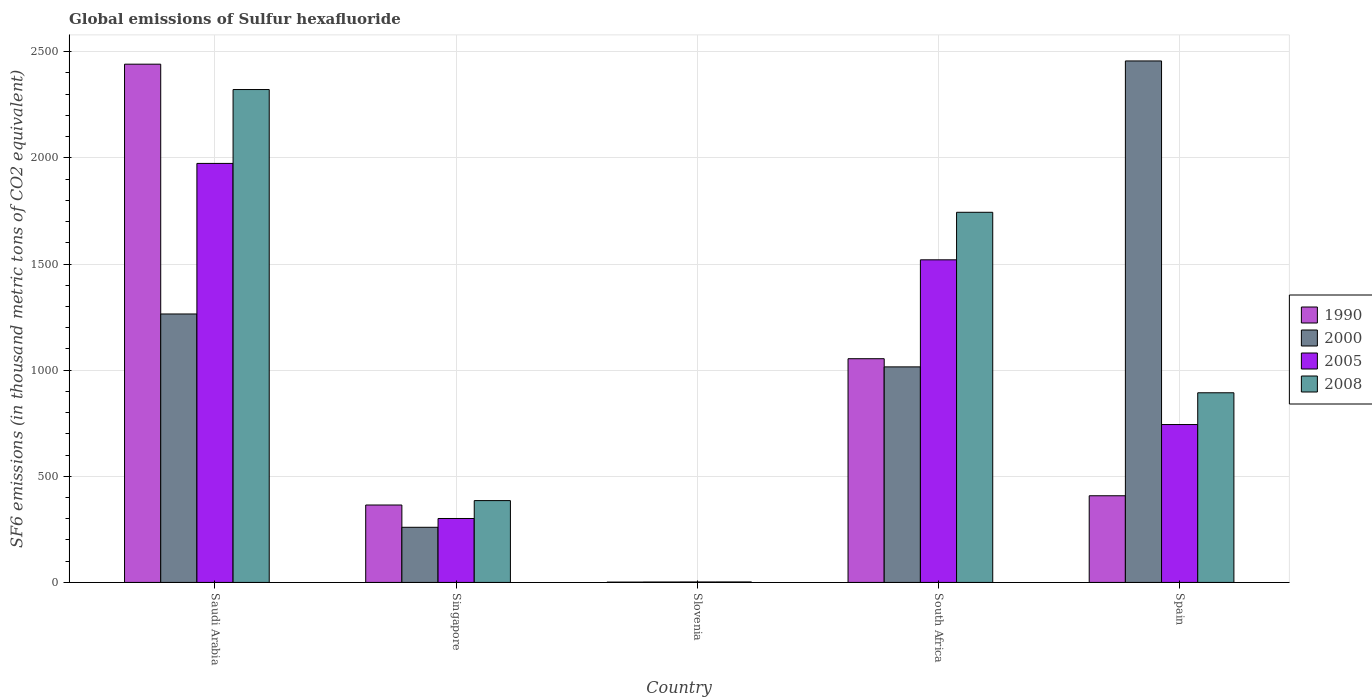How many different coloured bars are there?
Your answer should be compact. 4. How many groups of bars are there?
Keep it short and to the point. 5. How many bars are there on the 1st tick from the left?
Your answer should be very brief. 4. How many bars are there on the 1st tick from the right?
Make the answer very short. 4. What is the label of the 3rd group of bars from the left?
Ensure brevity in your answer.  Slovenia. In how many cases, is the number of bars for a given country not equal to the number of legend labels?
Provide a succinct answer. 0. What is the global emissions of Sulfur hexafluoride in 2000 in Singapore?
Give a very brief answer. 259.8. Across all countries, what is the maximum global emissions of Sulfur hexafluoride in 1990?
Make the answer very short. 2441.3. In which country was the global emissions of Sulfur hexafluoride in 2000 maximum?
Your answer should be compact. Spain. In which country was the global emissions of Sulfur hexafluoride in 2000 minimum?
Keep it short and to the point. Slovenia. What is the total global emissions of Sulfur hexafluoride in 2000 in the graph?
Offer a terse response. 4998.3. What is the difference between the global emissions of Sulfur hexafluoride in 2000 in Slovenia and that in Spain?
Make the answer very short. -2454.5. What is the difference between the global emissions of Sulfur hexafluoride in 2005 in Slovenia and the global emissions of Sulfur hexafluoride in 1990 in Singapore?
Ensure brevity in your answer.  -362.5. What is the average global emissions of Sulfur hexafluoride in 2005 per country?
Give a very brief answer. 908.14. What is the difference between the global emissions of Sulfur hexafluoride of/in 2000 and global emissions of Sulfur hexafluoride of/in 1990 in Spain?
Offer a very short reply. 2048.2. What is the ratio of the global emissions of Sulfur hexafluoride in 2005 in South Africa to that in Spain?
Keep it short and to the point. 2.04. Is the difference between the global emissions of Sulfur hexafluoride in 2000 in Singapore and Slovenia greater than the difference between the global emissions of Sulfur hexafluoride in 1990 in Singapore and Slovenia?
Ensure brevity in your answer.  No. What is the difference between the highest and the second highest global emissions of Sulfur hexafluoride in 1990?
Offer a very short reply. -2033. What is the difference between the highest and the lowest global emissions of Sulfur hexafluoride in 1990?
Make the answer very short. 2439.7. Is it the case that in every country, the sum of the global emissions of Sulfur hexafluoride in 2008 and global emissions of Sulfur hexafluoride in 2005 is greater than the sum of global emissions of Sulfur hexafluoride in 2000 and global emissions of Sulfur hexafluoride in 1990?
Provide a succinct answer. No. Is it the case that in every country, the sum of the global emissions of Sulfur hexafluoride in 1990 and global emissions of Sulfur hexafluoride in 2008 is greater than the global emissions of Sulfur hexafluoride in 2000?
Your response must be concise. No. How many bars are there?
Your response must be concise. 20. What is the difference between two consecutive major ticks on the Y-axis?
Your response must be concise. 500. Are the values on the major ticks of Y-axis written in scientific E-notation?
Offer a terse response. No. Does the graph contain any zero values?
Your answer should be compact. No. Does the graph contain grids?
Offer a very short reply. Yes. Where does the legend appear in the graph?
Offer a very short reply. Center right. How many legend labels are there?
Give a very brief answer. 4. How are the legend labels stacked?
Your answer should be very brief. Vertical. What is the title of the graph?
Provide a short and direct response. Global emissions of Sulfur hexafluoride. Does "1997" appear as one of the legend labels in the graph?
Ensure brevity in your answer.  No. What is the label or title of the Y-axis?
Provide a succinct answer. SF6 emissions (in thousand metric tons of CO2 equivalent). What is the SF6 emissions (in thousand metric tons of CO2 equivalent) of 1990 in Saudi Arabia?
Provide a short and direct response. 2441.3. What is the SF6 emissions (in thousand metric tons of CO2 equivalent) in 2000 in Saudi Arabia?
Give a very brief answer. 1264.6. What is the SF6 emissions (in thousand metric tons of CO2 equivalent) of 2005 in Saudi Arabia?
Keep it short and to the point. 1973.8. What is the SF6 emissions (in thousand metric tons of CO2 equivalent) of 2008 in Saudi Arabia?
Provide a short and direct response. 2321.8. What is the SF6 emissions (in thousand metric tons of CO2 equivalent) of 1990 in Singapore?
Give a very brief answer. 364.7. What is the SF6 emissions (in thousand metric tons of CO2 equivalent) in 2000 in Singapore?
Your response must be concise. 259.8. What is the SF6 emissions (in thousand metric tons of CO2 equivalent) in 2005 in Singapore?
Offer a terse response. 301.2. What is the SF6 emissions (in thousand metric tons of CO2 equivalent) in 2008 in Singapore?
Make the answer very short. 385.5. What is the SF6 emissions (in thousand metric tons of CO2 equivalent) in 2000 in Slovenia?
Offer a terse response. 2. What is the SF6 emissions (in thousand metric tons of CO2 equivalent) of 2005 in Slovenia?
Provide a short and direct response. 2.2. What is the SF6 emissions (in thousand metric tons of CO2 equivalent) in 1990 in South Africa?
Your response must be concise. 1053.9. What is the SF6 emissions (in thousand metric tons of CO2 equivalent) in 2000 in South Africa?
Keep it short and to the point. 1015.4. What is the SF6 emissions (in thousand metric tons of CO2 equivalent) in 2005 in South Africa?
Make the answer very short. 1519.7. What is the SF6 emissions (in thousand metric tons of CO2 equivalent) of 2008 in South Africa?
Provide a short and direct response. 1743.6. What is the SF6 emissions (in thousand metric tons of CO2 equivalent) of 1990 in Spain?
Ensure brevity in your answer.  408.3. What is the SF6 emissions (in thousand metric tons of CO2 equivalent) in 2000 in Spain?
Keep it short and to the point. 2456.5. What is the SF6 emissions (in thousand metric tons of CO2 equivalent) in 2005 in Spain?
Provide a succinct answer. 743.8. What is the SF6 emissions (in thousand metric tons of CO2 equivalent) in 2008 in Spain?
Offer a very short reply. 893.4. Across all countries, what is the maximum SF6 emissions (in thousand metric tons of CO2 equivalent) in 1990?
Your answer should be very brief. 2441.3. Across all countries, what is the maximum SF6 emissions (in thousand metric tons of CO2 equivalent) in 2000?
Your response must be concise. 2456.5. Across all countries, what is the maximum SF6 emissions (in thousand metric tons of CO2 equivalent) of 2005?
Provide a short and direct response. 1973.8. Across all countries, what is the maximum SF6 emissions (in thousand metric tons of CO2 equivalent) in 2008?
Provide a succinct answer. 2321.8. Across all countries, what is the minimum SF6 emissions (in thousand metric tons of CO2 equivalent) in 2000?
Offer a terse response. 2. Across all countries, what is the minimum SF6 emissions (in thousand metric tons of CO2 equivalent) of 2008?
Offer a very short reply. 2.3. What is the total SF6 emissions (in thousand metric tons of CO2 equivalent) of 1990 in the graph?
Offer a terse response. 4269.8. What is the total SF6 emissions (in thousand metric tons of CO2 equivalent) of 2000 in the graph?
Give a very brief answer. 4998.3. What is the total SF6 emissions (in thousand metric tons of CO2 equivalent) of 2005 in the graph?
Your response must be concise. 4540.7. What is the total SF6 emissions (in thousand metric tons of CO2 equivalent) in 2008 in the graph?
Offer a terse response. 5346.6. What is the difference between the SF6 emissions (in thousand metric tons of CO2 equivalent) of 1990 in Saudi Arabia and that in Singapore?
Provide a succinct answer. 2076.6. What is the difference between the SF6 emissions (in thousand metric tons of CO2 equivalent) of 2000 in Saudi Arabia and that in Singapore?
Make the answer very short. 1004.8. What is the difference between the SF6 emissions (in thousand metric tons of CO2 equivalent) in 2005 in Saudi Arabia and that in Singapore?
Your answer should be compact. 1672.6. What is the difference between the SF6 emissions (in thousand metric tons of CO2 equivalent) in 2008 in Saudi Arabia and that in Singapore?
Provide a short and direct response. 1936.3. What is the difference between the SF6 emissions (in thousand metric tons of CO2 equivalent) of 1990 in Saudi Arabia and that in Slovenia?
Provide a succinct answer. 2439.7. What is the difference between the SF6 emissions (in thousand metric tons of CO2 equivalent) in 2000 in Saudi Arabia and that in Slovenia?
Ensure brevity in your answer.  1262.6. What is the difference between the SF6 emissions (in thousand metric tons of CO2 equivalent) in 2005 in Saudi Arabia and that in Slovenia?
Keep it short and to the point. 1971.6. What is the difference between the SF6 emissions (in thousand metric tons of CO2 equivalent) of 2008 in Saudi Arabia and that in Slovenia?
Your answer should be very brief. 2319.5. What is the difference between the SF6 emissions (in thousand metric tons of CO2 equivalent) in 1990 in Saudi Arabia and that in South Africa?
Your answer should be compact. 1387.4. What is the difference between the SF6 emissions (in thousand metric tons of CO2 equivalent) in 2000 in Saudi Arabia and that in South Africa?
Provide a short and direct response. 249.2. What is the difference between the SF6 emissions (in thousand metric tons of CO2 equivalent) of 2005 in Saudi Arabia and that in South Africa?
Your response must be concise. 454.1. What is the difference between the SF6 emissions (in thousand metric tons of CO2 equivalent) in 2008 in Saudi Arabia and that in South Africa?
Provide a succinct answer. 578.2. What is the difference between the SF6 emissions (in thousand metric tons of CO2 equivalent) in 1990 in Saudi Arabia and that in Spain?
Give a very brief answer. 2033. What is the difference between the SF6 emissions (in thousand metric tons of CO2 equivalent) of 2000 in Saudi Arabia and that in Spain?
Your answer should be compact. -1191.9. What is the difference between the SF6 emissions (in thousand metric tons of CO2 equivalent) of 2005 in Saudi Arabia and that in Spain?
Your response must be concise. 1230. What is the difference between the SF6 emissions (in thousand metric tons of CO2 equivalent) in 2008 in Saudi Arabia and that in Spain?
Ensure brevity in your answer.  1428.4. What is the difference between the SF6 emissions (in thousand metric tons of CO2 equivalent) in 1990 in Singapore and that in Slovenia?
Ensure brevity in your answer.  363.1. What is the difference between the SF6 emissions (in thousand metric tons of CO2 equivalent) in 2000 in Singapore and that in Slovenia?
Provide a succinct answer. 257.8. What is the difference between the SF6 emissions (in thousand metric tons of CO2 equivalent) of 2005 in Singapore and that in Slovenia?
Ensure brevity in your answer.  299. What is the difference between the SF6 emissions (in thousand metric tons of CO2 equivalent) of 2008 in Singapore and that in Slovenia?
Offer a terse response. 383.2. What is the difference between the SF6 emissions (in thousand metric tons of CO2 equivalent) in 1990 in Singapore and that in South Africa?
Offer a terse response. -689.2. What is the difference between the SF6 emissions (in thousand metric tons of CO2 equivalent) of 2000 in Singapore and that in South Africa?
Ensure brevity in your answer.  -755.6. What is the difference between the SF6 emissions (in thousand metric tons of CO2 equivalent) in 2005 in Singapore and that in South Africa?
Your answer should be very brief. -1218.5. What is the difference between the SF6 emissions (in thousand metric tons of CO2 equivalent) in 2008 in Singapore and that in South Africa?
Make the answer very short. -1358.1. What is the difference between the SF6 emissions (in thousand metric tons of CO2 equivalent) of 1990 in Singapore and that in Spain?
Keep it short and to the point. -43.6. What is the difference between the SF6 emissions (in thousand metric tons of CO2 equivalent) of 2000 in Singapore and that in Spain?
Your response must be concise. -2196.7. What is the difference between the SF6 emissions (in thousand metric tons of CO2 equivalent) in 2005 in Singapore and that in Spain?
Provide a succinct answer. -442.6. What is the difference between the SF6 emissions (in thousand metric tons of CO2 equivalent) of 2008 in Singapore and that in Spain?
Make the answer very short. -507.9. What is the difference between the SF6 emissions (in thousand metric tons of CO2 equivalent) of 1990 in Slovenia and that in South Africa?
Offer a very short reply. -1052.3. What is the difference between the SF6 emissions (in thousand metric tons of CO2 equivalent) of 2000 in Slovenia and that in South Africa?
Provide a short and direct response. -1013.4. What is the difference between the SF6 emissions (in thousand metric tons of CO2 equivalent) in 2005 in Slovenia and that in South Africa?
Ensure brevity in your answer.  -1517.5. What is the difference between the SF6 emissions (in thousand metric tons of CO2 equivalent) in 2008 in Slovenia and that in South Africa?
Your response must be concise. -1741.3. What is the difference between the SF6 emissions (in thousand metric tons of CO2 equivalent) in 1990 in Slovenia and that in Spain?
Your response must be concise. -406.7. What is the difference between the SF6 emissions (in thousand metric tons of CO2 equivalent) of 2000 in Slovenia and that in Spain?
Your answer should be very brief. -2454.5. What is the difference between the SF6 emissions (in thousand metric tons of CO2 equivalent) in 2005 in Slovenia and that in Spain?
Provide a succinct answer. -741.6. What is the difference between the SF6 emissions (in thousand metric tons of CO2 equivalent) of 2008 in Slovenia and that in Spain?
Offer a very short reply. -891.1. What is the difference between the SF6 emissions (in thousand metric tons of CO2 equivalent) in 1990 in South Africa and that in Spain?
Provide a short and direct response. 645.6. What is the difference between the SF6 emissions (in thousand metric tons of CO2 equivalent) of 2000 in South Africa and that in Spain?
Ensure brevity in your answer.  -1441.1. What is the difference between the SF6 emissions (in thousand metric tons of CO2 equivalent) in 2005 in South Africa and that in Spain?
Provide a succinct answer. 775.9. What is the difference between the SF6 emissions (in thousand metric tons of CO2 equivalent) of 2008 in South Africa and that in Spain?
Your answer should be very brief. 850.2. What is the difference between the SF6 emissions (in thousand metric tons of CO2 equivalent) in 1990 in Saudi Arabia and the SF6 emissions (in thousand metric tons of CO2 equivalent) in 2000 in Singapore?
Make the answer very short. 2181.5. What is the difference between the SF6 emissions (in thousand metric tons of CO2 equivalent) of 1990 in Saudi Arabia and the SF6 emissions (in thousand metric tons of CO2 equivalent) of 2005 in Singapore?
Your response must be concise. 2140.1. What is the difference between the SF6 emissions (in thousand metric tons of CO2 equivalent) in 1990 in Saudi Arabia and the SF6 emissions (in thousand metric tons of CO2 equivalent) in 2008 in Singapore?
Your response must be concise. 2055.8. What is the difference between the SF6 emissions (in thousand metric tons of CO2 equivalent) in 2000 in Saudi Arabia and the SF6 emissions (in thousand metric tons of CO2 equivalent) in 2005 in Singapore?
Make the answer very short. 963.4. What is the difference between the SF6 emissions (in thousand metric tons of CO2 equivalent) of 2000 in Saudi Arabia and the SF6 emissions (in thousand metric tons of CO2 equivalent) of 2008 in Singapore?
Offer a terse response. 879.1. What is the difference between the SF6 emissions (in thousand metric tons of CO2 equivalent) of 2005 in Saudi Arabia and the SF6 emissions (in thousand metric tons of CO2 equivalent) of 2008 in Singapore?
Your response must be concise. 1588.3. What is the difference between the SF6 emissions (in thousand metric tons of CO2 equivalent) of 1990 in Saudi Arabia and the SF6 emissions (in thousand metric tons of CO2 equivalent) of 2000 in Slovenia?
Your answer should be compact. 2439.3. What is the difference between the SF6 emissions (in thousand metric tons of CO2 equivalent) of 1990 in Saudi Arabia and the SF6 emissions (in thousand metric tons of CO2 equivalent) of 2005 in Slovenia?
Make the answer very short. 2439.1. What is the difference between the SF6 emissions (in thousand metric tons of CO2 equivalent) in 1990 in Saudi Arabia and the SF6 emissions (in thousand metric tons of CO2 equivalent) in 2008 in Slovenia?
Your answer should be compact. 2439. What is the difference between the SF6 emissions (in thousand metric tons of CO2 equivalent) of 2000 in Saudi Arabia and the SF6 emissions (in thousand metric tons of CO2 equivalent) of 2005 in Slovenia?
Offer a terse response. 1262.4. What is the difference between the SF6 emissions (in thousand metric tons of CO2 equivalent) of 2000 in Saudi Arabia and the SF6 emissions (in thousand metric tons of CO2 equivalent) of 2008 in Slovenia?
Ensure brevity in your answer.  1262.3. What is the difference between the SF6 emissions (in thousand metric tons of CO2 equivalent) in 2005 in Saudi Arabia and the SF6 emissions (in thousand metric tons of CO2 equivalent) in 2008 in Slovenia?
Keep it short and to the point. 1971.5. What is the difference between the SF6 emissions (in thousand metric tons of CO2 equivalent) in 1990 in Saudi Arabia and the SF6 emissions (in thousand metric tons of CO2 equivalent) in 2000 in South Africa?
Provide a succinct answer. 1425.9. What is the difference between the SF6 emissions (in thousand metric tons of CO2 equivalent) of 1990 in Saudi Arabia and the SF6 emissions (in thousand metric tons of CO2 equivalent) of 2005 in South Africa?
Your response must be concise. 921.6. What is the difference between the SF6 emissions (in thousand metric tons of CO2 equivalent) in 1990 in Saudi Arabia and the SF6 emissions (in thousand metric tons of CO2 equivalent) in 2008 in South Africa?
Your response must be concise. 697.7. What is the difference between the SF6 emissions (in thousand metric tons of CO2 equivalent) in 2000 in Saudi Arabia and the SF6 emissions (in thousand metric tons of CO2 equivalent) in 2005 in South Africa?
Make the answer very short. -255.1. What is the difference between the SF6 emissions (in thousand metric tons of CO2 equivalent) of 2000 in Saudi Arabia and the SF6 emissions (in thousand metric tons of CO2 equivalent) of 2008 in South Africa?
Provide a succinct answer. -479. What is the difference between the SF6 emissions (in thousand metric tons of CO2 equivalent) in 2005 in Saudi Arabia and the SF6 emissions (in thousand metric tons of CO2 equivalent) in 2008 in South Africa?
Your answer should be compact. 230.2. What is the difference between the SF6 emissions (in thousand metric tons of CO2 equivalent) in 1990 in Saudi Arabia and the SF6 emissions (in thousand metric tons of CO2 equivalent) in 2000 in Spain?
Your answer should be very brief. -15.2. What is the difference between the SF6 emissions (in thousand metric tons of CO2 equivalent) of 1990 in Saudi Arabia and the SF6 emissions (in thousand metric tons of CO2 equivalent) of 2005 in Spain?
Offer a very short reply. 1697.5. What is the difference between the SF6 emissions (in thousand metric tons of CO2 equivalent) in 1990 in Saudi Arabia and the SF6 emissions (in thousand metric tons of CO2 equivalent) in 2008 in Spain?
Give a very brief answer. 1547.9. What is the difference between the SF6 emissions (in thousand metric tons of CO2 equivalent) in 2000 in Saudi Arabia and the SF6 emissions (in thousand metric tons of CO2 equivalent) in 2005 in Spain?
Your answer should be compact. 520.8. What is the difference between the SF6 emissions (in thousand metric tons of CO2 equivalent) of 2000 in Saudi Arabia and the SF6 emissions (in thousand metric tons of CO2 equivalent) of 2008 in Spain?
Make the answer very short. 371.2. What is the difference between the SF6 emissions (in thousand metric tons of CO2 equivalent) of 2005 in Saudi Arabia and the SF6 emissions (in thousand metric tons of CO2 equivalent) of 2008 in Spain?
Make the answer very short. 1080.4. What is the difference between the SF6 emissions (in thousand metric tons of CO2 equivalent) in 1990 in Singapore and the SF6 emissions (in thousand metric tons of CO2 equivalent) in 2000 in Slovenia?
Provide a succinct answer. 362.7. What is the difference between the SF6 emissions (in thousand metric tons of CO2 equivalent) of 1990 in Singapore and the SF6 emissions (in thousand metric tons of CO2 equivalent) of 2005 in Slovenia?
Give a very brief answer. 362.5. What is the difference between the SF6 emissions (in thousand metric tons of CO2 equivalent) in 1990 in Singapore and the SF6 emissions (in thousand metric tons of CO2 equivalent) in 2008 in Slovenia?
Offer a very short reply. 362.4. What is the difference between the SF6 emissions (in thousand metric tons of CO2 equivalent) of 2000 in Singapore and the SF6 emissions (in thousand metric tons of CO2 equivalent) of 2005 in Slovenia?
Your response must be concise. 257.6. What is the difference between the SF6 emissions (in thousand metric tons of CO2 equivalent) in 2000 in Singapore and the SF6 emissions (in thousand metric tons of CO2 equivalent) in 2008 in Slovenia?
Make the answer very short. 257.5. What is the difference between the SF6 emissions (in thousand metric tons of CO2 equivalent) in 2005 in Singapore and the SF6 emissions (in thousand metric tons of CO2 equivalent) in 2008 in Slovenia?
Your answer should be compact. 298.9. What is the difference between the SF6 emissions (in thousand metric tons of CO2 equivalent) of 1990 in Singapore and the SF6 emissions (in thousand metric tons of CO2 equivalent) of 2000 in South Africa?
Provide a short and direct response. -650.7. What is the difference between the SF6 emissions (in thousand metric tons of CO2 equivalent) in 1990 in Singapore and the SF6 emissions (in thousand metric tons of CO2 equivalent) in 2005 in South Africa?
Offer a very short reply. -1155. What is the difference between the SF6 emissions (in thousand metric tons of CO2 equivalent) of 1990 in Singapore and the SF6 emissions (in thousand metric tons of CO2 equivalent) of 2008 in South Africa?
Provide a short and direct response. -1378.9. What is the difference between the SF6 emissions (in thousand metric tons of CO2 equivalent) of 2000 in Singapore and the SF6 emissions (in thousand metric tons of CO2 equivalent) of 2005 in South Africa?
Keep it short and to the point. -1259.9. What is the difference between the SF6 emissions (in thousand metric tons of CO2 equivalent) of 2000 in Singapore and the SF6 emissions (in thousand metric tons of CO2 equivalent) of 2008 in South Africa?
Your answer should be compact. -1483.8. What is the difference between the SF6 emissions (in thousand metric tons of CO2 equivalent) of 2005 in Singapore and the SF6 emissions (in thousand metric tons of CO2 equivalent) of 2008 in South Africa?
Your answer should be compact. -1442.4. What is the difference between the SF6 emissions (in thousand metric tons of CO2 equivalent) in 1990 in Singapore and the SF6 emissions (in thousand metric tons of CO2 equivalent) in 2000 in Spain?
Offer a very short reply. -2091.8. What is the difference between the SF6 emissions (in thousand metric tons of CO2 equivalent) in 1990 in Singapore and the SF6 emissions (in thousand metric tons of CO2 equivalent) in 2005 in Spain?
Your response must be concise. -379.1. What is the difference between the SF6 emissions (in thousand metric tons of CO2 equivalent) in 1990 in Singapore and the SF6 emissions (in thousand metric tons of CO2 equivalent) in 2008 in Spain?
Give a very brief answer. -528.7. What is the difference between the SF6 emissions (in thousand metric tons of CO2 equivalent) of 2000 in Singapore and the SF6 emissions (in thousand metric tons of CO2 equivalent) of 2005 in Spain?
Offer a very short reply. -484. What is the difference between the SF6 emissions (in thousand metric tons of CO2 equivalent) in 2000 in Singapore and the SF6 emissions (in thousand metric tons of CO2 equivalent) in 2008 in Spain?
Offer a very short reply. -633.6. What is the difference between the SF6 emissions (in thousand metric tons of CO2 equivalent) in 2005 in Singapore and the SF6 emissions (in thousand metric tons of CO2 equivalent) in 2008 in Spain?
Offer a terse response. -592.2. What is the difference between the SF6 emissions (in thousand metric tons of CO2 equivalent) in 1990 in Slovenia and the SF6 emissions (in thousand metric tons of CO2 equivalent) in 2000 in South Africa?
Make the answer very short. -1013.8. What is the difference between the SF6 emissions (in thousand metric tons of CO2 equivalent) in 1990 in Slovenia and the SF6 emissions (in thousand metric tons of CO2 equivalent) in 2005 in South Africa?
Give a very brief answer. -1518.1. What is the difference between the SF6 emissions (in thousand metric tons of CO2 equivalent) of 1990 in Slovenia and the SF6 emissions (in thousand metric tons of CO2 equivalent) of 2008 in South Africa?
Your response must be concise. -1742. What is the difference between the SF6 emissions (in thousand metric tons of CO2 equivalent) of 2000 in Slovenia and the SF6 emissions (in thousand metric tons of CO2 equivalent) of 2005 in South Africa?
Keep it short and to the point. -1517.7. What is the difference between the SF6 emissions (in thousand metric tons of CO2 equivalent) in 2000 in Slovenia and the SF6 emissions (in thousand metric tons of CO2 equivalent) in 2008 in South Africa?
Give a very brief answer. -1741.6. What is the difference between the SF6 emissions (in thousand metric tons of CO2 equivalent) of 2005 in Slovenia and the SF6 emissions (in thousand metric tons of CO2 equivalent) of 2008 in South Africa?
Give a very brief answer. -1741.4. What is the difference between the SF6 emissions (in thousand metric tons of CO2 equivalent) in 1990 in Slovenia and the SF6 emissions (in thousand metric tons of CO2 equivalent) in 2000 in Spain?
Make the answer very short. -2454.9. What is the difference between the SF6 emissions (in thousand metric tons of CO2 equivalent) in 1990 in Slovenia and the SF6 emissions (in thousand metric tons of CO2 equivalent) in 2005 in Spain?
Offer a terse response. -742.2. What is the difference between the SF6 emissions (in thousand metric tons of CO2 equivalent) of 1990 in Slovenia and the SF6 emissions (in thousand metric tons of CO2 equivalent) of 2008 in Spain?
Make the answer very short. -891.8. What is the difference between the SF6 emissions (in thousand metric tons of CO2 equivalent) of 2000 in Slovenia and the SF6 emissions (in thousand metric tons of CO2 equivalent) of 2005 in Spain?
Make the answer very short. -741.8. What is the difference between the SF6 emissions (in thousand metric tons of CO2 equivalent) in 2000 in Slovenia and the SF6 emissions (in thousand metric tons of CO2 equivalent) in 2008 in Spain?
Keep it short and to the point. -891.4. What is the difference between the SF6 emissions (in thousand metric tons of CO2 equivalent) of 2005 in Slovenia and the SF6 emissions (in thousand metric tons of CO2 equivalent) of 2008 in Spain?
Ensure brevity in your answer.  -891.2. What is the difference between the SF6 emissions (in thousand metric tons of CO2 equivalent) in 1990 in South Africa and the SF6 emissions (in thousand metric tons of CO2 equivalent) in 2000 in Spain?
Make the answer very short. -1402.6. What is the difference between the SF6 emissions (in thousand metric tons of CO2 equivalent) of 1990 in South Africa and the SF6 emissions (in thousand metric tons of CO2 equivalent) of 2005 in Spain?
Ensure brevity in your answer.  310.1. What is the difference between the SF6 emissions (in thousand metric tons of CO2 equivalent) of 1990 in South Africa and the SF6 emissions (in thousand metric tons of CO2 equivalent) of 2008 in Spain?
Ensure brevity in your answer.  160.5. What is the difference between the SF6 emissions (in thousand metric tons of CO2 equivalent) in 2000 in South Africa and the SF6 emissions (in thousand metric tons of CO2 equivalent) in 2005 in Spain?
Provide a short and direct response. 271.6. What is the difference between the SF6 emissions (in thousand metric tons of CO2 equivalent) of 2000 in South Africa and the SF6 emissions (in thousand metric tons of CO2 equivalent) of 2008 in Spain?
Provide a succinct answer. 122. What is the difference between the SF6 emissions (in thousand metric tons of CO2 equivalent) in 2005 in South Africa and the SF6 emissions (in thousand metric tons of CO2 equivalent) in 2008 in Spain?
Provide a short and direct response. 626.3. What is the average SF6 emissions (in thousand metric tons of CO2 equivalent) in 1990 per country?
Ensure brevity in your answer.  853.96. What is the average SF6 emissions (in thousand metric tons of CO2 equivalent) of 2000 per country?
Your response must be concise. 999.66. What is the average SF6 emissions (in thousand metric tons of CO2 equivalent) of 2005 per country?
Provide a short and direct response. 908.14. What is the average SF6 emissions (in thousand metric tons of CO2 equivalent) of 2008 per country?
Provide a short and direct response. 1069.32. What is the difference between the SF6 emissions (in thousand metric tons of CO2 equivalent) of 1990 and SF6 emissions (in thousand metric tons of CO2 equivalent) of 2000 in Saudi Arabia?
Ensure brevity in your answer.  1176.7. What is the difference between the SF6 emissions (in thousand metric tons of CO2 equivalent) of 1990 and SF6 emissions (in thousand metric tons of CO2 equivalent) of 2005 in Saudi Arabia?
Provide a succinct answer. 467.5. What is the difference between the SF6 emissions (in thousand metric tons of CO2 equivalent) in 1990 and SF6 emissions (in thousand metric tons of CO2 equivalent) in 2008 in Saudi Arabia?
Your answer should be very brief. 119.5. What is the difference between the SF6 emissions (in thousand metric tons of CO2 equivalent) of 2000 and SF6 emissions (in thousand metric tons of CO2 equivalent) of 2005 in Saudi Arabia?
Provide a succinct answer. -709.2. What is the difference between the SF6 emissions (in thousand metric tons of CO2 equivalent) in 2000 and SF6 emissions (in thousand metric tons of CO2 equivalent) in 2008 in Saudi Arabia?
Your answer should be very brief. -1057.2. What is the difference between the SF6 emissions (in thousand metric tons of CO2 equivalent) of 2005 and SF6 emissions (in thousand metric tons of CO2 equivalent) of 2008 in Saudi Arabia?
Offer a terse response. -348. What is the difference between the SF6 emissions (in thousand metric tons of CO2 equivalent) of 1990 and SF6 emissions (in thousand metric tons of CO2 equivalent) of 2000 in Singapore?
Provide a succinct answer. 104.9. What is the difference between the SF6 emissions (in thousand metric tons of CO2 equivalent) in 1990 and SF6 emissions (in thousand metric tons of CO2 equivalent) in 2005 in Singapore?
Make the answer very short. 63.5. What is the difference between the SF6 emissions (in thousand metric tons of CO2 equivalent) of 1990 and SF6 emissions (in thousand metric tons of CO2 equivalent) of 2008 in Singapore?
Give a very brief answer. -20.8. What is the difference between the SF6 emissions (in thousand metric tons of CO2 equivalent) of 2000 and SF6 emissions (in thousand metric tons of CO2 equivalent) of 2005 in Singapore?
Your answer should be very brief. -41.4. What is the difference between the SF6 emissions (in thousand metric tons of CO2 equivalent) of 2000 and SF6 emissions (in thousand metric tons of CO2 equivalent) of 2008 in Singapore?
Offer a very short reply. -125.7. What is the difference between the SF6 emissions (in thousand metric tons of CO2 equivalent) of 2005 and SF6 emissions (in thousand metric tons of CO2 equivalent) of 2008 in Singapore?
Keep it short and to the point. -84.3. What is the difference between the SF6 emissions (in thousand metric tons of CO2 equivalent) of 1990 and SF6 emissions (in thousand metric tons of CO2 equivalent) of 2000 in Slovenia?
Give a very brief answer. -0.4. What is the difference between the SF6 emissions (in thousand metric tons of CO2 equivalent) in 1990 and SF6 emissions (in thousand metric tons of CO2 equivalent) in 2000 in South Africa?
Make the answer very short. 38.5. What is the difference between the SF6 emissions (in thousand metric tons of CO2 equivalent) in 1990 and SF6 emissions (in thousand metric tons of CO2 equivalent) in 2005 in South Africa?
Make the answer very short. -465.8. What is the difference between the SF6 emissions (in thousand metric tons of CO2 equivalent) of 1990 and SF6 emissions (in thousand metric tons of CO2 equivalent) of 2008 in South Africa?
Your answer should be compact. -689.7. What is the difference between the SF6 emissions (in thousand metric tons of CO2 equivalent) of 2000 and SF6 emissions (in thousand metric tons of CO2 equivalent) of 2005 in South Africa?
Provide a short and direct response. -504.3. What is the difference between the SF6 emissions (in thousand metric tons of CO2 equivalent) in 2000 and SF6 emissions (in thousand metric tons of CO2 equivalent) in 2008 in South Africa?
Offer a terse response. -728.2. What is the difference between the SF6 emissions (in thousand metric tons of CO2 equivalent) of 2005 and SF6 emissions (in thousand metric tons of CO2 equivalent) of 2008 in South Africa?
Your answer should be very brief. -223.9. What is the difference between the SF6 emissions (in thousand metric tons of CO2 equivalent) of 1990 and SF6 emissions (in thousand metric tons of CO2 equivalent) of 2000 in Spain?
Provide a succinct answer. -2048.2. What is the difference between the SF6 emissions (in thousand metric tons of CO2 equivalent) of 1990 and SF6 emissions (in thousand metric tons of CO2 equivalent) of 2005 in Spain?
Ensure brevity in your answer.  -335.5. What is the difference between the SF6 emissions (in thousand metric tons of CO2 equivalent) of 1990 and SF6 emissions (in thousand metric tons of CO2 equivalent) of 2008 in Spain?
Give a very brief answer. -485.1. What is the difference between the SF6 emissions (in thousand metric tons of CO2 equivalent) in 2000 and SF6 emissions (in thousand metric tons of CO2 equivalent) in 2005 in Spain?
Ensure brevity in your answer.  1712.7. What is the difference between the SF6 emissions (in thousand metric tons of CO2 equivalent) of 2000 and SF6 emissions (in thousand metric tons of CO2 equivalent) of 2008 in Spain?
Provide a short and direct response. 1563.1. What is the difference between the SF6 emissions (in thousand metric tons of CO2 equivalent) of 2005 and SF6 emissions (in thousand metric tons of CO2 equivalent) of 2008 in Spain?
Make the answer very short. -149.6. What is the ratio of the SF6 emissions (in thousand metric tons of CO2 equivalent) in 1990 in Saudi Arabia to that in Singapore?
Make the answer very short. 6.69. What is the ratio of the SF6 emissions (in thousand metric tons of CO2 equivalent) of 2000 in Saudi Arabia to that in Singapore?
Keep it short and to the point. 4.87. What is the ratio of the SF6 emissions (in thousand metric tons of CO2 equivalent) of 2005 in Saudi Arabia to that in Singapore?
Provide a succinct answer. 6.55. What is the ratio of the SF6 emissions (in thousand metric tons of CO2 equivalent) of 2008 in Saudi Arabia to that in Singapore?
Make the answer very short. 6.02. What is the ratio of the SF6 emissions (in thousand metric tons of CO2 equivalent) in 1990 in Saudi Arabia to that in Slovenia?
Provide a succinct answer. 1525.81. What is the ratio of the SF6 emissions (in thousand metric tons of CO2 equivalent) in 2000 in Saudi Arabia to that in Slovenia?
Offer a very short reply. 632.3. What is the ratio of the SF6 emissions (in thousand metric tons of CO2 equivalent) in 2005 in Saudi Arabia to that in Slovenia?
Give a very brief answer. 897.18. What is the ratio of the SF6 emissions (in thousand metric tons of CO2 equivalent) of 2008 in Saudi Arabia to that in Slovenia?
Give a very brief answer. 1009.48. What is the ratio of the SF6 emissions (in thousand metric tons of CO2 equivalent) in 1990 in Saudi Arabia to that in South Africa?
Your answer should be very brief. 2.32. What is the ratio of the SF6 emissions (in thousand metric tons of CO2 equivalent) in 2000 in Saudi Arabia to that in South Africa?
Your response must be concise. 1.25. What is the ratio of the SF6 emissions (in thousand metric tons of CO2 equivalent) in 2005 in Saudi Arabia to that in South Africa?
Make the answer very short. 1.3. What is the ratio of the SF6 emissions (in thousand metric tons of CO2 equivalent) of 2008 in Saudi Arabia to that in South Africa?
Your answer should be compact. 1.33. What is the ratio of the SF6 emissions (in thousand metric tons of CO2 equivalent) in 1990 in Saudi Arabia to that in Spain?
Your response must be concise. 5.98. What is the ratio of the SF6 emissions (in thousand metric tons of CO2 equivalent) in 2000 in Saudi Arabia to that in Spain?
Provide a short and direct response. 0.51. What is the ratio of the SF6 emissions (in thousand metric tons of CO2 equivalent) in 2005 in Saudi Arabia to that in Spain?
Provide a succinct answer. 2.65. What is the ratio of the SF6 emissions (in thousand metric tons of CO2 equivalent) of 2008 in Saudi Arabia to that in Spain?
Provide a short and direct response. 2.6. What is the ratio of the SF6 emissions (in thousand metric tons of CO2 equivalent) of 1990 in Singapore to that in Slovenia?
Keep it short and to the point. 227.94. What is the ratio of the SF6 emissions (in thousand metric tons of CO2 equivalent) in 2000 in Singapore to that in Slovenia?
Provide a short and direct response. 129.9. What is the ratio of the SF6 emissions (in thousand metric tons of CO2 equivalent) in 2005 in Singapore to that in Slovenia?
Offer a very short reply. 136.91. What is the ratio of the SF6 emissions (in thousand metric tons of CO2 equivalent) in 2008 in Singapore to that in Slovenia?
Make the answer very short. 167.61. What is the ratio of the SF6 emissions (in thousand metric tons of CO2 equivalent) in 1990 in Singapore to that in South Africa?
Keep it short and to the point. 0.35. What is the ratio of the SF6 emissions (in thousand metric tons of CO2 equivalent) of 2000 in Singapore to that in South Africa?
Offer a terse response. 0.26. What is the ratio of the SF6 emissions (in thousand metric tons of CO2 equivalent) in 2005 in Singapore to that in South Africa?
Provide a succinct answer. 0.2. What is the ratio of the SF6 emissions (in thousand metric tons of CO2 equivalent) of 2008 in Singapore to that in South Africa?
Keep it short and to the point. 0.22. What is the ratio of the SF6 emissions (in thousand metric tons of CO2 equivalent) in 1990 in Singapore to that in Spain?
Give a very brief answer. 0.89. What is the ratio of the SF6 emissions (in thousand metric tons of CO2 equivalent) of 2000 in Singapore to that in Spain?
Ensure brevity in your answer.  0.11. What is the ratio of the SF6 emissions (in thousand metric tons of CO2 equivalent) of 2005 in Singapore to that in Spain?
Provide a short and direct response. 0.4. What is the ratio of the SF6 emissions (in thousand metric tons of CO2 equivalent) of 2008 in Singapore to that in Spain?
Offer a very short reply. 0.43. What is the ratio of the SF6 emissions (in thousand metric tons of CO2 equivalent) of 1990 in Slovenia to that in South Africa?
Offer a terse response. 0. What is the ratio of the SF6 emissions (in thousand metric tons of CO2 equivalent) of 2000 in Slovenia to that in South Africa?
Offer a very short reply. 0. What is the ratio of the SF6 emissions (in thousand metric tons of CO2 equivalent) of 2005 in Slovenia to that in South Africa?
Give a very brief answer. 0. What is the ratio of the SF6 emissions (in thousand metric tons of CO2 equivalent) of 2008 in Slovenia to that in South Africa?
Provide a succinct answer. 0. What is the ratio of the SF6 emissions (in thousand metric tons of CO2 equivalent) of 1990 in Slovenia to that in Spain?
Offer a terse response. 0. What is the ratio of the SF6 emissions (in thousand metric tons of CO2 equivalent) of 2000 in Slovenia to that in Spain?
Give a very brief answer. 0. What is the ratio of the SF6 emissions (in thousand metric tons of CO2 equivalent) of 2005 in Slovenia to that in Spain?
Offer a terse response. 0. What is the ratio of the SF6 emissions (in thousand metric tons of CO2 equivalent) in 2008 in Slovenia to that in Spain?
Your answer should be compact. 0. What is the ratio of the SF6 emissions (in thousand metric tons of CO2 equivalent) in 1990 in South Africa to that in Spain?
Ensure brevity in your answer.  2.58. What is the ratio of the SF6 emissions (in thousand metric tons of CO2 equivalent) in 2000 in South Africa to that in Spain?
Offer a terse response. 0.41. What is the ratio of the SF6 emissions (in thousand metric tons of CO2 equivalent) in 2005 in South Africa to that in Spain?
Offer a very short reply. 2.04. What is the ratio of the SF6 emissions (in thousand metric tons of CO2 equivalent) of 2008 in South Africa to that in Spain?
Your answer should be compact. 1.95. What is the difference between the highest and the second highest SF6 emissions (in thousand metric tons of CO2 equivalent) of 1990?
Offer a very short reply. 1387.4. What is the difference between the highest and the second highest SF6 emissions (in thousand metric tons of CO2 equivalent) in 2000?
Give a very brief answer. 1191.9. What is the difference between the highest and the second highest SF6 emissions (in thousand metric tons of CO2 equivalent) of 2005?
Keep it short and to the point. 454.1. What is the difference between the highest and the second highest SF6 emissions (in thousand metric tons of CO2 equivalent) in 2008?
Offer a terse response. 578.2. What is the difference between the highest and the lowest SF6 emissions (in thousand metric tons of CO2 equivalent) in 1990?
Keep it short and to the point. 2439.7. What is the difference between the highest and the lowest SF6 emissions (in thousand metric tons of CO2 equivalent) of 2000?
Provide a short and direct response. 2454.5. What is the difference between the highest and the lowest SF6 emissions (in thousand metric tons of CO2 equivalent) of 2005?
Provide a succinct answer. 1971.6. What is the difference between the highest and the lowest SF6 emissions (in thousand metric tons of CO2 equivalent) in 2008?
Make the answer very short. 2319.5. 